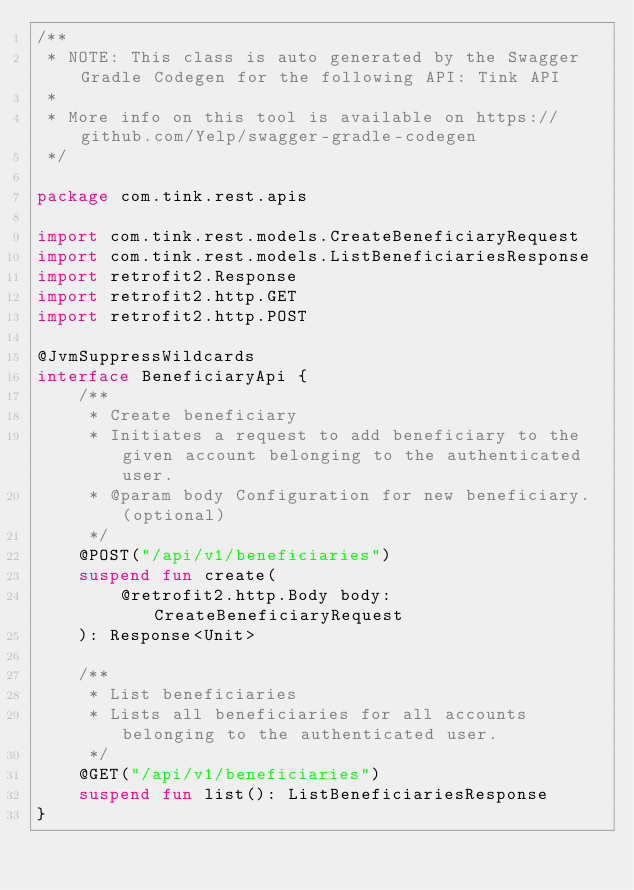<code> <loc_0><loc_0><loc_500><loc_500><_Kotlin_>/**
 * NOTE: This class is auto generated by the Swagger Gradle Codegen for the following API: Tink API
 *
 * More info on this tool is available on https://github.com/Yelp/swagger-gradle-codegen
 */

package com.tink.rest.apis

import com.tink.rest.models.CreateBeneficiaryRequest
import com.tink.rest.models.ListBeneficiariesResponse
import retrofit2.Response
import retrofit2.http.GET
import retrofit2.http.POST

@JvmSuppressWildcards
interface BeneficiaryApi {
    /**
     * Create beneficiary
     * Initiates a request to add beneficiary to the given account belonging to the authenticated user.
     * @param body Configuration for new beneficiary. (optional)
     */
    @POST("/api/v1/beneficiaries")
    suspend fun create(
        @retrofit2.http.Body body: CreateBeneficiaryRequest
    ): Response<Unit>

    /**
     * List beneficiaries
     * Lists all beneficiaries for all accounts belonging to the authenticated user.
     */
    @GET("/api/v1/beneficiaries")
    suspend fun list(): ListBeneficiariesResponse
}
</code> 